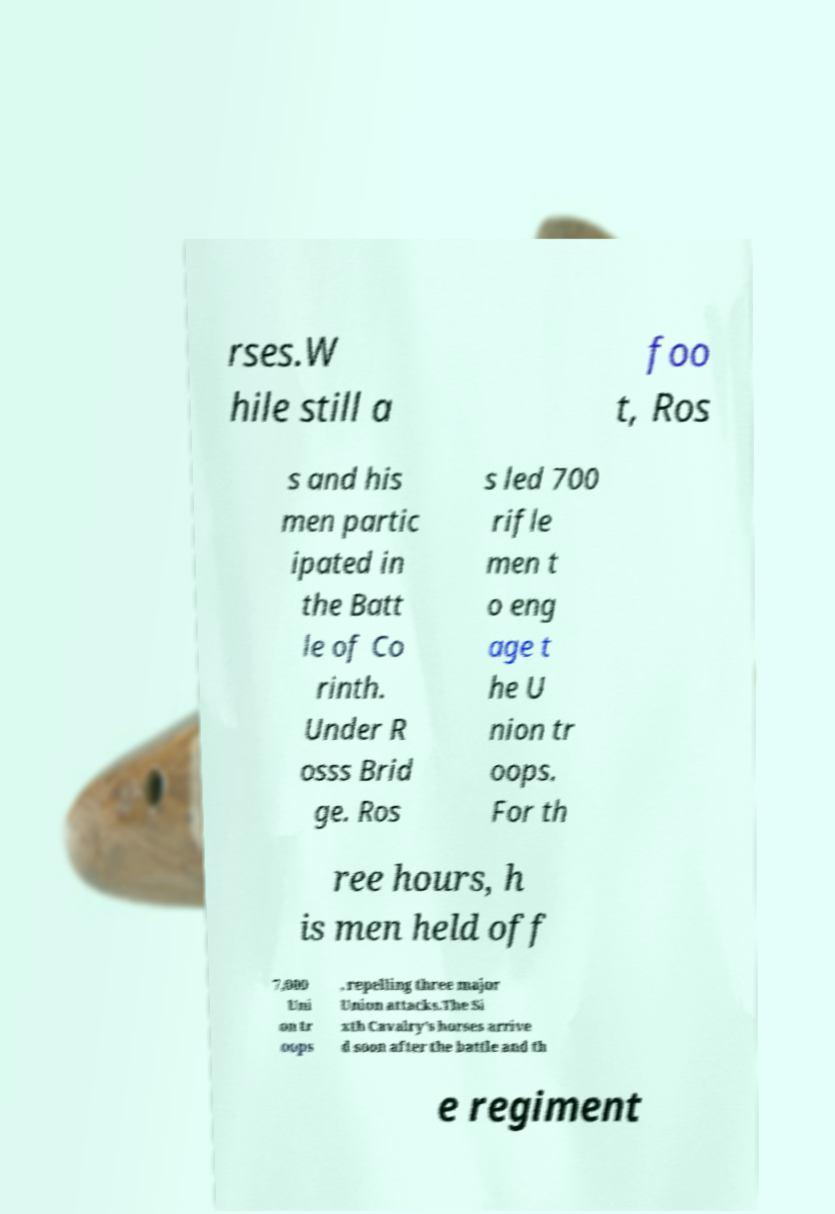I need the written content from this picture converted into text. Can you do that? rses.W hile still a foo t, Ros s and his men partic ipated in the Batt le of Co rinth. Under R osss Brid ge. Ros s led 700 rifle men t o eng age t he U nion tr oops. For th ree hours, h is men held off 7,000 Uni on tr oops , repelling three major Union attacks.The Si xth Cavalry's horses arrive d soon after the battle and th e regiment 